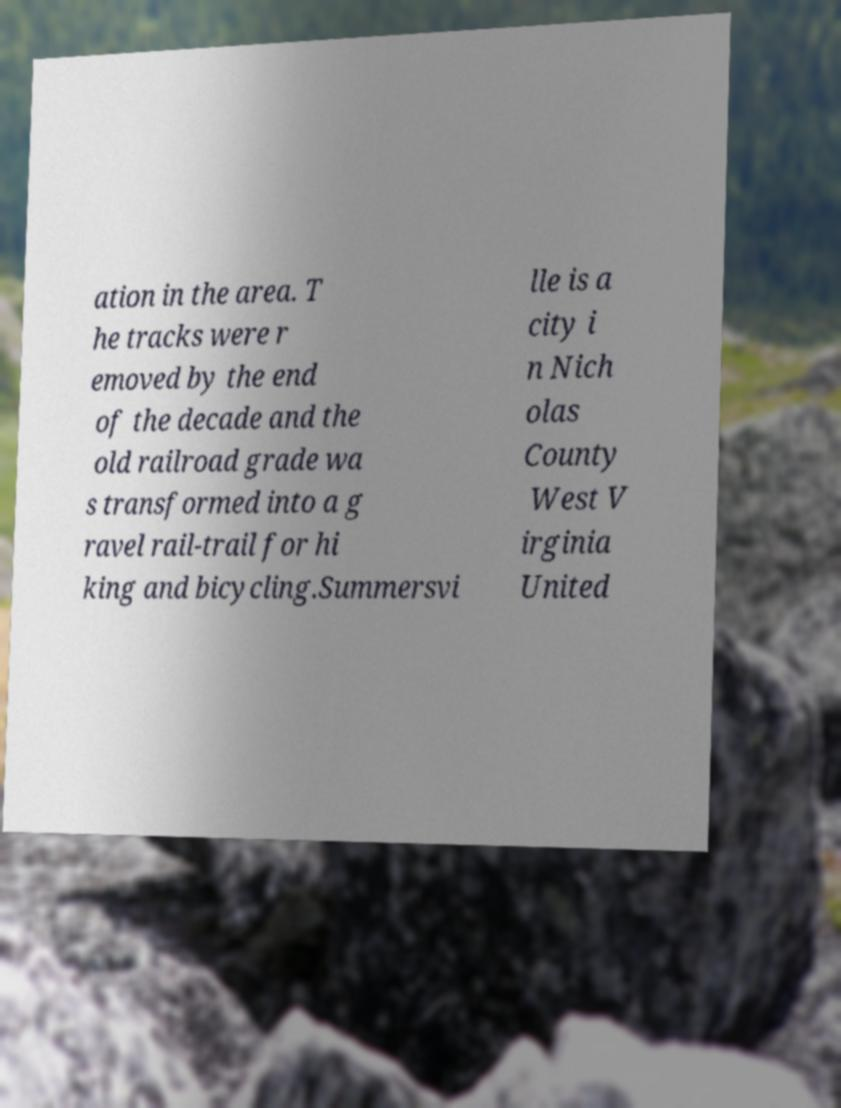Can you read and provide the text displayed in the image?This photo seems to have some interesting text. Can you extract and type it out for me? ation in the area. T he tracks were r emoved by the end of the decade and the old railroad grade wa s transformed into a g ravel rail-trail for hi king and bicycling.Summersvi lle is a city i n Nich olas County West V irginia United 